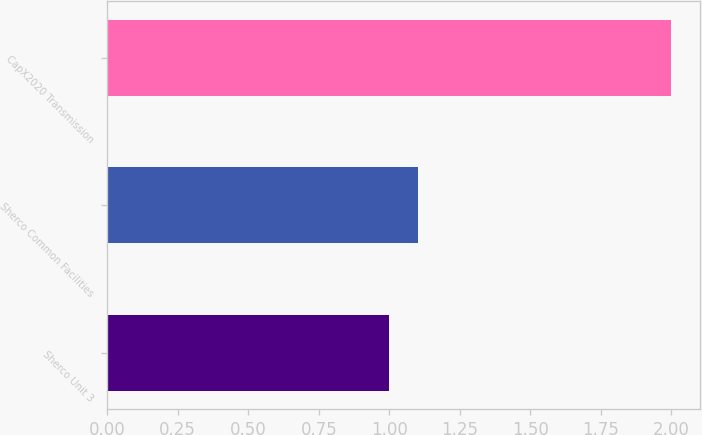Convert chart. <chart><loc_0><loc_0><loc_500><loc_500><bar_chart><fcel>Sherco Unit 3<fcel>Sherco Common Facilities<fcel>CapX2020 Transmission<nl><fcel>1<fcel>1.1<fcel>2<nl></chart> 